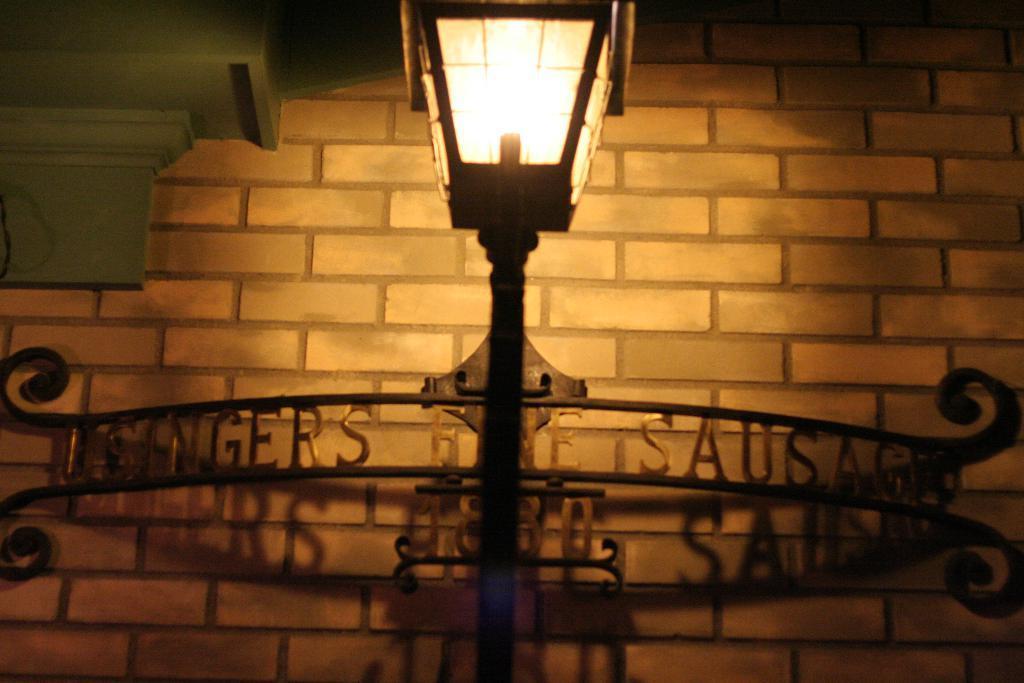Please provide a concise description of this image. In the center of this picture we can see a lamp post. In the background we can see the brick wall and the text attached to the metal objects. 